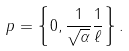<formula> <loc_0><loc_0><loc_500><loc_500>p = \left \{ 0 , \frac { 1 } { \sqrt { \alpha } } \frac { 1 } { \ell } \right \} .</formula> 